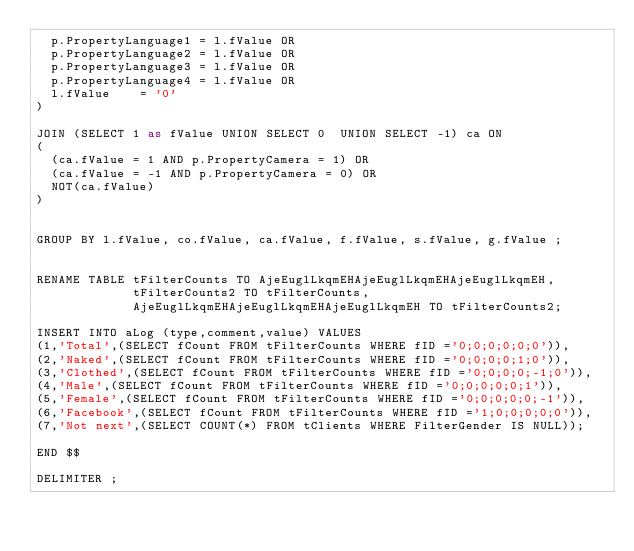<code> <loc_0><loc_0><loc_500><loc_500><_SQL_>  p.PropertyLanguage1 = l.fValue OR
  p.PropertyLanguage2 = l.fValue OR
  p.PropertyLanguage3 = l.fValue OR
  p.PropertyLanguage4 = l.fValue OR
  l.fValue    = '0'
)

JOIN (SELECT 1 as fValue UNION SELECT 0  UNION SELECT -1) ca ON
(
  (ca.fValue = 1 AND p.PropertyCamera = 1) OR
  (ca.fValue = -1 AND p.PropertyCamera = 0) OR
  NOT(ca.fValue)
)


GROUP BY l.fValue, co.fValue, ca.fValue, f.fValue, s.fValue, g.fValue ;


RENAME TABLE tFilterCounts TO AjeEuglLkqmEHAjeEuglLkqmEHAjeEuglLkqmEH,
             tFilterCounts2 TO tFilterCounts,
             AjeEuglLkqmEHAjeEuglLkqmEHAjeEuglLkqmEH TO tFilterCounts2;

INSERT INTO aLog (type,comment,value) VALUES
(1,'Total',(SELECT fCount FROM tFilterCounts WHERE fID ='0;0;0;0;0;0')),
(2,'Naked',(SELECT fCount FROM tFilterCounts WHERE fID ='0;0;0;0;1;0')),
(3,'Clothed',(SELECT fCount FROM tFilterCounts WHERE fID ='0;0;0;0;-1;0')),
(4,'Male',(SELECT fCount FROM tFilterCounts WHERE fID ='0;0;0;0;0;1')),
(5,'Female',(SELECT fCount FROM tFilterCounts WHERE fID ='0;0;0;0;0;-1')),
(6,'Facebook',(SELECT fCount FROM tFilterCounts WHERE fID ='1;0;0;0;0;0')),
(7,'Not next',(SELECT COUNT(*) FROM tClients WHERE FilterGender IS NULL));

END $$

DELIMITER ;</code> 